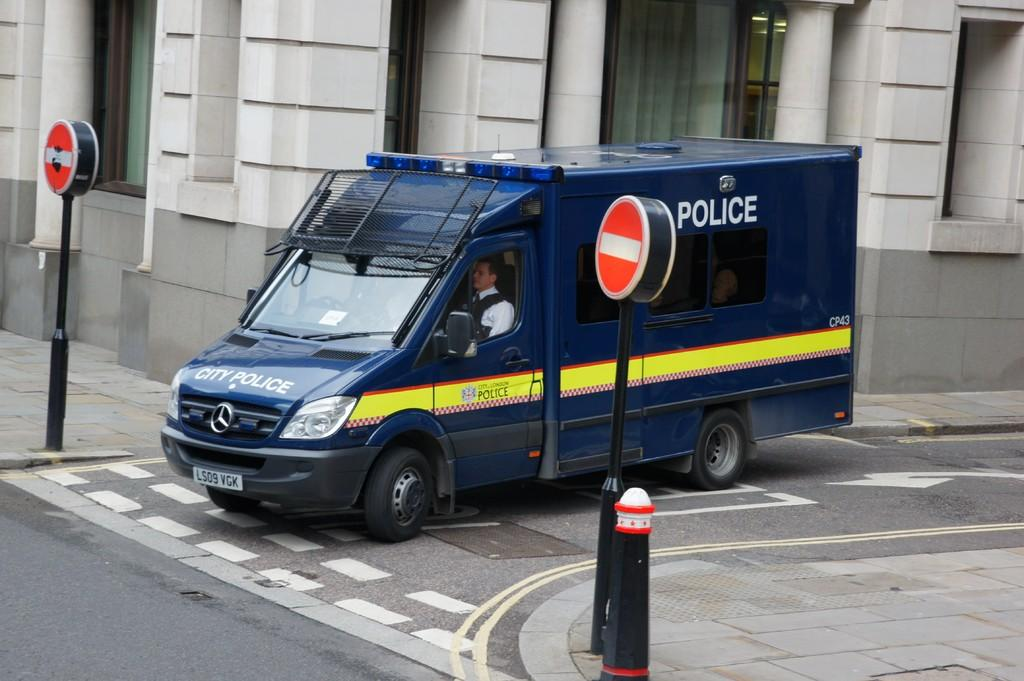<image>
Share a concise interpretation of the image provided. A large blue Police van sits at the junction of a city street. 